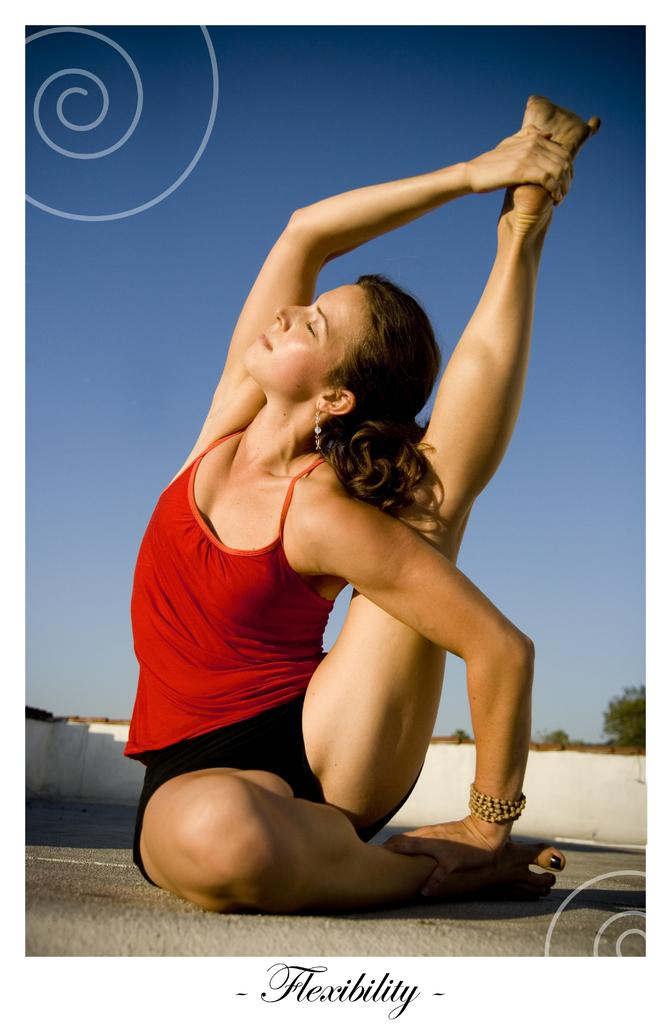What is the main subject of the image? The main subject of the image is a woman. What is the woman doing in the image? The woman is performing exercise in the image. What color is the top the woman is wearing? The woman is wearing a red color top. What type of scent can be detected from the woman's top in the image? There is no information about the scent of the woman's top in the image, so it cannot be determined. 